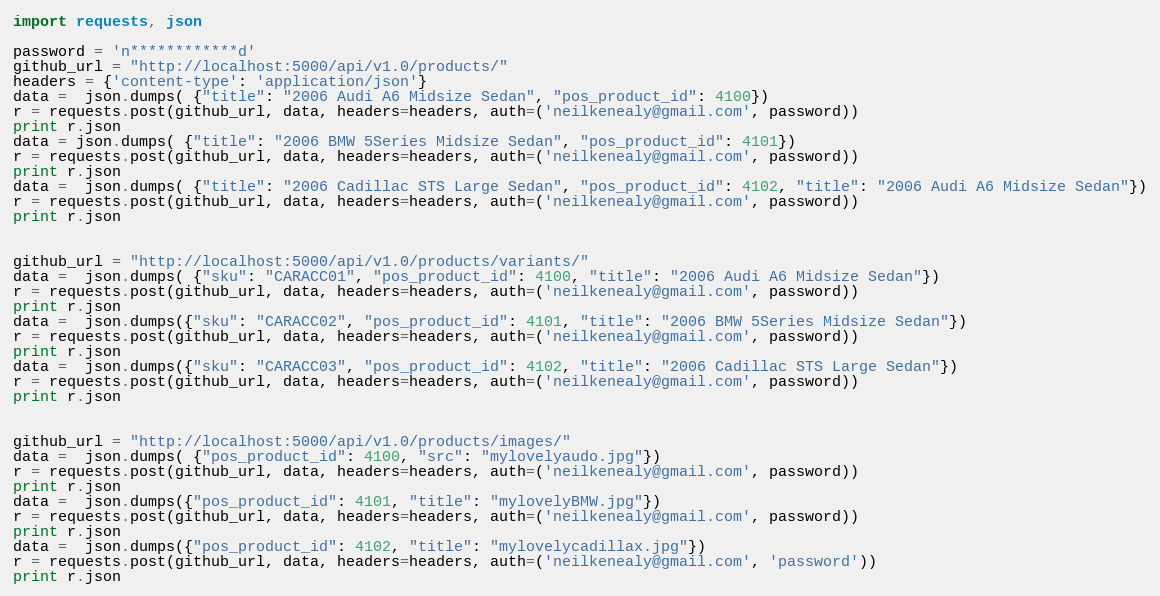<code> <loc_0><loc_0><loc_500><loc_500><_Python_>import requests, json

password = 'n************d'
github_url = "http://localhost:5000/api/v1.0/products/"
headers = {'content-type': 'application/json'}
data =  json.dumps( {"title": "2006 Audi A6 Midsize Sedan", "pos_product_id": 4100})
r = requests.post(github_url, data, headers=headers, auth=('neilkenealy@gmail.com', password))
print r.json
data = json.dumps( {"title": "2006 BMW 5Series Midsize Sedan", "pos_product_id": 4101})
r = requests.post(github_url, data, headers=headers, auth=('neilkenealy@gmail.com', password))
print r.json
data =  json.dumps( {"title": "2006 Cadillac STS Large Sedan", "pos_product_id": 4102, "title": "2006 Audi A6 Midsize Sedan"})
r = requests.post(github_url, data, headers=headers, auth=('neilkenealy@gmail.com', password))
print r.json


github_url = "http://localhost:5000/api/v1.0/products/variants/"
data =  json.dumps( {"sku": "CARACC01", "pos_product_id": 4100, "title": "2006 Audi A6 Midsize Sedan"})
r = requests.post(github_url, data, headers=headers, auth=('neilkenealy@gmail.com', password))
print r.json
data =  json.dumps({"sku": "CARACC02", "pos_product_id": 4101, "title": "2006 BMW 5Series Midsize Sedan"})
r = requests.post(github_url, data, headers=headers, auth=('neilkenealy@gmail.com', password))
print r.json
data =  json.dumps({"sku": "CARACC03", "pos_product_id": 4102, "title": "2006 Cadillac STS Large Sedan"})
r = requests.post(github_url, data, headers=headers, auth=('neilkenealy@gmail.com', password))
print r.json


github_url = "http://localhost:5000/api/v1.0/products/images/"
data =  json.dumps( {"pos_product_id": 4100, "src": "mylovelyaudo.jpg"})
r = requests.post(github_url, data, headers=headers, auth=('neilkenealy@gmail.com', password))
print r.json
data =  json.dumps({"pos_product_id": 4101, "title": "mylovelyBMW.jpg"})
r = requests.post(github_url, data, headers=headers, auth=('neilkenealy@gmail.com', password))
print r.json
data =  json.dumps({"pos_product_id": 4102, "title": "mylovelycadillax.jpg"})
r = requests.post(github_url, data, headers=headers, auth=('neilkenealy@gmail.com', 'password'))
print r.json


</code> 